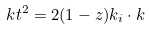<formula> <loc_0><loc_0><loc_500><loc_500>\ k t ^ { 2 } = 2 ( 1 - z ) k _ { i } \cdot k \,</formula> 